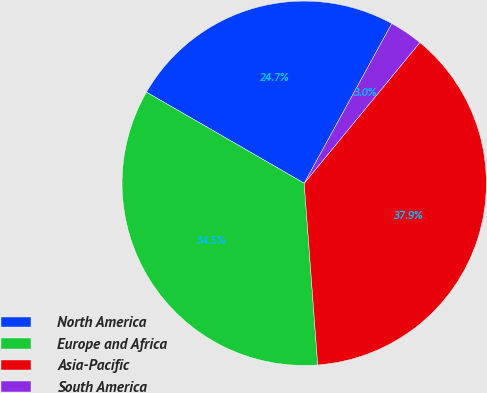<chart> <loc_0><loc_0><loc_500><loc_500><pie_chart><fcel>North America<fcel>Europe and Africa<fcel>Asia-Pacific<fcel>South America<nl><fcel>24.65%<fcel>34.52%<fcel>37.87%<fcel>2.96%<nl></chart> 